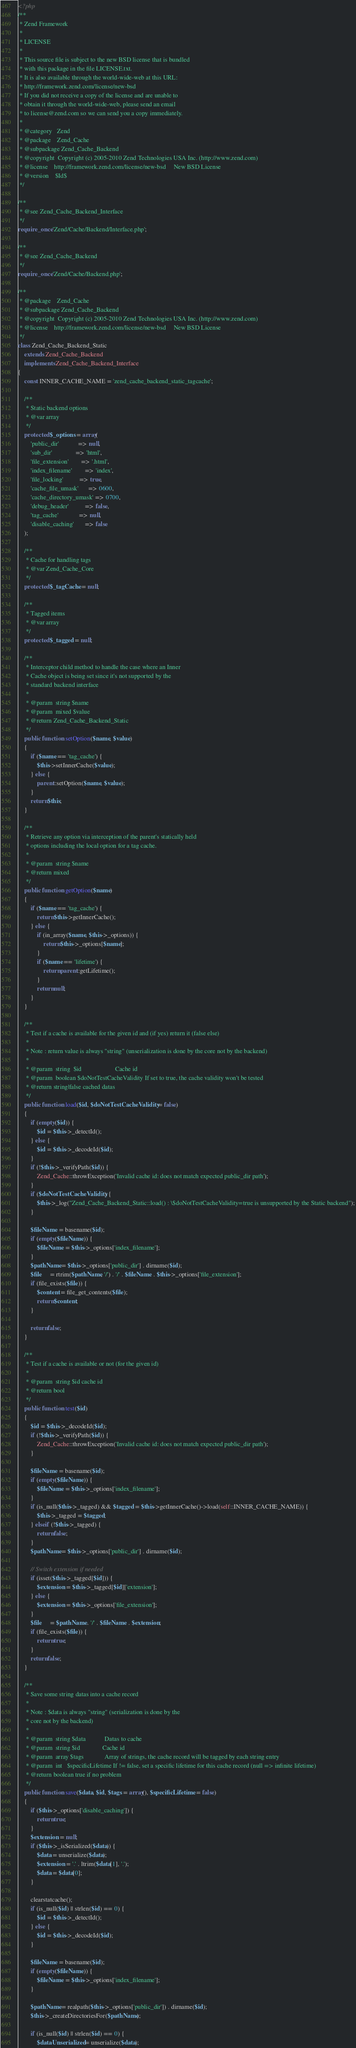<code> <loc_0><loc_0><loc_500><loc_500><_PHP_><?php
/**
 * Zend Framework
 *
 * LICENSE
 *
 * This source file is subject to the new BSD license that is bundled
 * with this package in the file LICENSE.txt.
 * It is also available through the world-wide-web at this URL:
 * http://framework.zend.com/license/new-bsd
 * If you did not receive a copy of the license and are unable to
 * obtain it through the world-wide-web, please send an email
 * to license@zend.com so we can send you a copy immediately.
 *
 * @category   Zend
 * @package    Zend_Cache
 * @subpackage Zend_Cache_Backend
 * @copyright  Copyright (c) 2005-2010 Zend Technologies USA Inc. (http://www.zend.com)
 * @license    http://framework.zend.com/license/new-bsd     New BSD License
 * @version    $Id$
 */

/**
 * @see Zend_Cache_Backend_Interface
 */
require_once 'Zend/Cache/Backend/Interface.php';

/**
 * @see Zend_Cache_Backend
 */
require_once 'Zend/Cache/Backend.php';

/**
 * @package    Zend_Cache
 * @subpackage Zend_Cache_Backend
 * @copyright  Copyright (c) 2005-2010 Zend Technologies USA Inc. (http://www.zend.com)
 * @license    http://framework.zend.com/license/new-bsd     New BSD License
 */
class Zend_Cache_Backend_Static 
    extends Zend_Cache_Backend 
    implements Zend_Cache_Backend_Interface
{
    const INNER_CACHE_NAME = 'zend_cache_backend_static_tagcache';

    /**
     * Static backend options
     * @var array
     */
    protected $_options = array(
        'public_dir'            => null,
        'sub_dir'               => 'html',
        'file_extension'        => '.html',
        'index_filename'        => 'index',
        'file_locking'          => true,
        'cache_file_umask'      => 0600,
        'cache_directory_umask' => 0700,
        'debug_header'          => false,
        'tag_cache'             => null,
        'disable_caching'       => false
    );

    /**
     * Cache for handling tags
     * @var Zend_Cache_Core
     */
    protected $_tagCache = null;

    /**
     * Tagged items
     * @var array
     */
    protected $_tagged = null;

    /**
     * Interceptor child method to handle the case where an Inner
     * Cache object is being set since it's not supported by the
     * standard backend interface
     *
     * @param  string $name
     * @param  mixed $value
     * @return Zend_Cache_Backend_Static
     */
    public function setOption($name, $value)
    {
        if ($name == 'tag_cache') {
            $this->setInnerCache($value);
        } else {
            parent::setOption($name, $value);
        }
        return $this;
    }

    /**
     * Retrieve any option via interception of the parent's statically held
     * options including the local option for a tag cache.
     *
     * @param  string $name
     * @return mixed
     */
    public function getOption($name)
    {
        if ($name == 'tag_cache') {
            return $this->getInnerCache();
        } else {
            if (in_array($name, $this->_options)) {
                return $this->_options[$name];
            }
            if ($name == 'lifetime') {
                return parent::getLifetime();
            }
            return null;
        }
    }

    /**
     * Test if a cache is available for the given id and (if yes) return it (false else)
     *
     * Note : return value is always "string" (unserialization is done by the core not by the backend)
     *
     * @param  string  $id                     Cache id
     * @param  boolean $doNotTestCacheValidity If set to true, the cache validity won't be tested
     * @return string|false cached datas
     */
    public function load($id, $doNotTestCacheValidity = false)
    {
        if (empty($id)) {
            $id = $this->_detectId();
        } else {
            $id = $this->_decodeId($id);
        }
        if (!$this->_verifyPath($id)) {
            Zend_Cache::throwException('Invalid cache id: does not match expected public_dir path');
        }
        if ($doNotTestCacheValidity) {
            $this->_log("Zend_Cache_Backend_Static::load() : \$doNotTestCacheValidity=true is unsupported by the Static backend");
        }

        $fileName = basename($id);
        if (empty($fileName)) {
            $fileName = $this->_options['index_filename'];
        }
        $pathName = $this->_options['public_dir'] . dirname($id);
        $file     = rtrim($pathName, '/') . '/' . $fileName . $this->_options['file_extension'];
        if (file_exists($file)) {
            $content = file_get_contents($file);
            return $content;
        }

        return false;
    }

    /**
     * Test if a cache is available or not (for the given id)
     *
     * @param  string $id cache id
     * @return bool 
     */
    public function test($id)
    {
        $id = $this->_decodeId($id);
        if (!$this->_verifyPath($id)) {
            Zend_Cache::throwException('Invalid cache id: does not match expected public_dir path');
        }

        $fileName = basename($id);
        if (empty($fileName)) {
            $fileName = $this->_options['index_filename'];
        }
        if (is_null($this->_tagged) && $tagged = $this->getInnerCache()->load(self::INNER_CACHE_NAME)) {
            $this->_tagged = $tagged;
        } elseif (!$this->_tagged) {
            return false;
        }
        $pathName = $this->_options['public_dir'] . dirname($id);
        
        // Switch extension if needed
        if (isset($this->_tagged[$id])) {
            $extension = $this->_tagged[$id]['extension'];
        } else {
            $extension = $this->_options['file_extension'];
        }
        $file     = $pathName . '/' . $fileName . $extension;
        if (file_exists($file)) {
            return true;
        }
        return false;
    }

    /**
     * Save some string datas into a cache record
     *
     * Note : $data is always "string" (serialization is done by the
     * core not by the backend)
     *
     * @param  string $data            Datas to cache
     * @param  string $id              Cache id
     * @param  array $tags             Array of strings, the cache record will be tagged by each string entry
     * @param  int   $specificLifetime If != false, set a specific lifetime for this cache record (null => infinite lifetime)
     * @return boolean true if no problem
     */
    public function save($data, $id, $tags = array(), $specificLifetime = false)
    {
        if ($this->_options['disable_caching']) {
            return true;
        }
        $extension = null;
        if ($this->_isSerialized($data)) {
            $data = unserialize($data);
            $extension = '.' . ltrim($data[1], '.');
            $data = $data[0];
        }

        clearstatcache();
        if (is_null($id) || strlen($id) == 0) {
            $id = $this->_detectId();
        } else {
            $id = $this->_decodeId($id);
        }

        $fileName = basename($id);
        if (empty($fileName)) {
            $fileName = $this->_options['index_filename'];
        }

        $pathName = realpath($this->_options['public_dir']) . dirname($id);
        $this->_createDirectoriesFor($pathName);

        if (is_null($id) || strlen($id) == 0) {
            $dataUnserialized = unserialize($data);</code> 